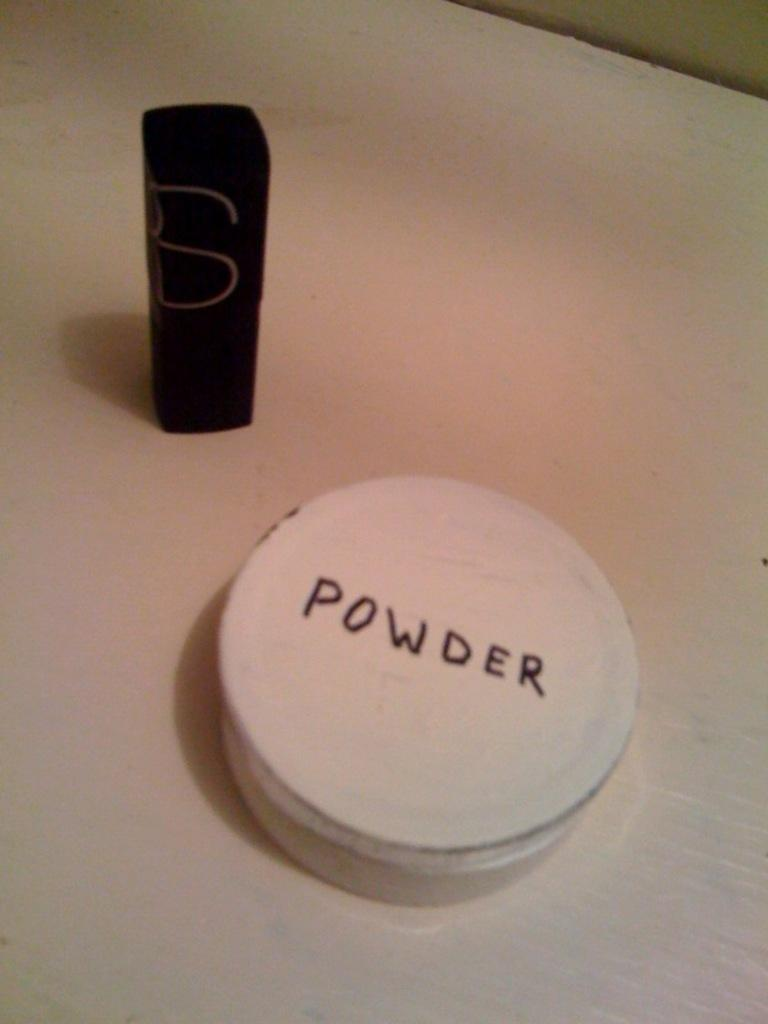<image>
Offer a succinct explanation of the picture presented. A small pad of POWDER sitting next to a lipstick case on the counter. 